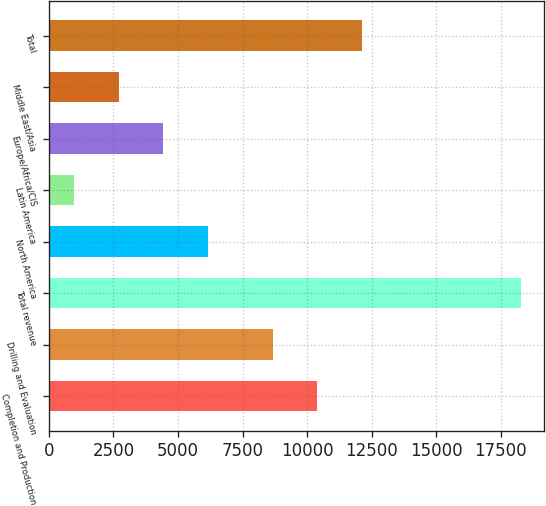Convert chart to OTSL. <chart><loc_0><loc_0><loc_500><loc_500><bar_chart><fcel>Completion and Production<fcel>Drilling and Evaluation<fcel>Total revenue<fcel>North America<fcel>Latin America<fcel>Europe/Africa/CIS<fcel>Middle East/Asia<fcel>Total<nl><fcel>10399.1<fcel>8669<fcel>18279<fcel>6168.3<fcel>978<fcel>4438.2<fcel>2708.1<fcel>12129.2<nl></chart> 